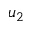Convert formula to latex. <formula><loc_0><loc_0><loc_500><loc_500>u _ { 2 }</formula> 